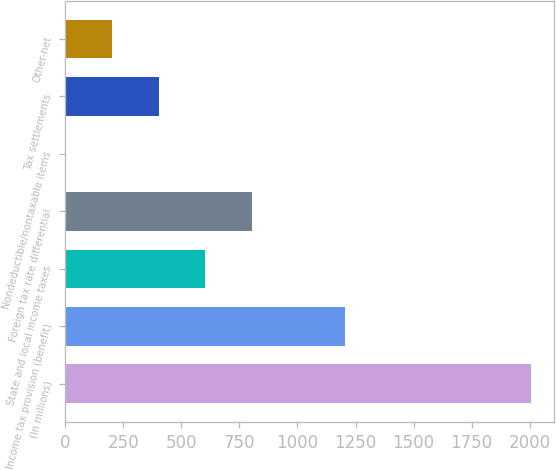<chart> <loc_0><loc_0><loc_500><loc_500><bar_chart><fcel>(In millions)<fcel>Income tax provision (benefit)<fcel>State and local income taxes<fcel>Foreign tax rate differential<fcel>Nondeductible/nontaxable items<fcel>Tax settlements<fcel>Other-net<nl><fcel>2006<fcel>1204<fcel>602.5<fcel>803<fcel>1<fcel>402<fcel>201.5<nl></chart> 